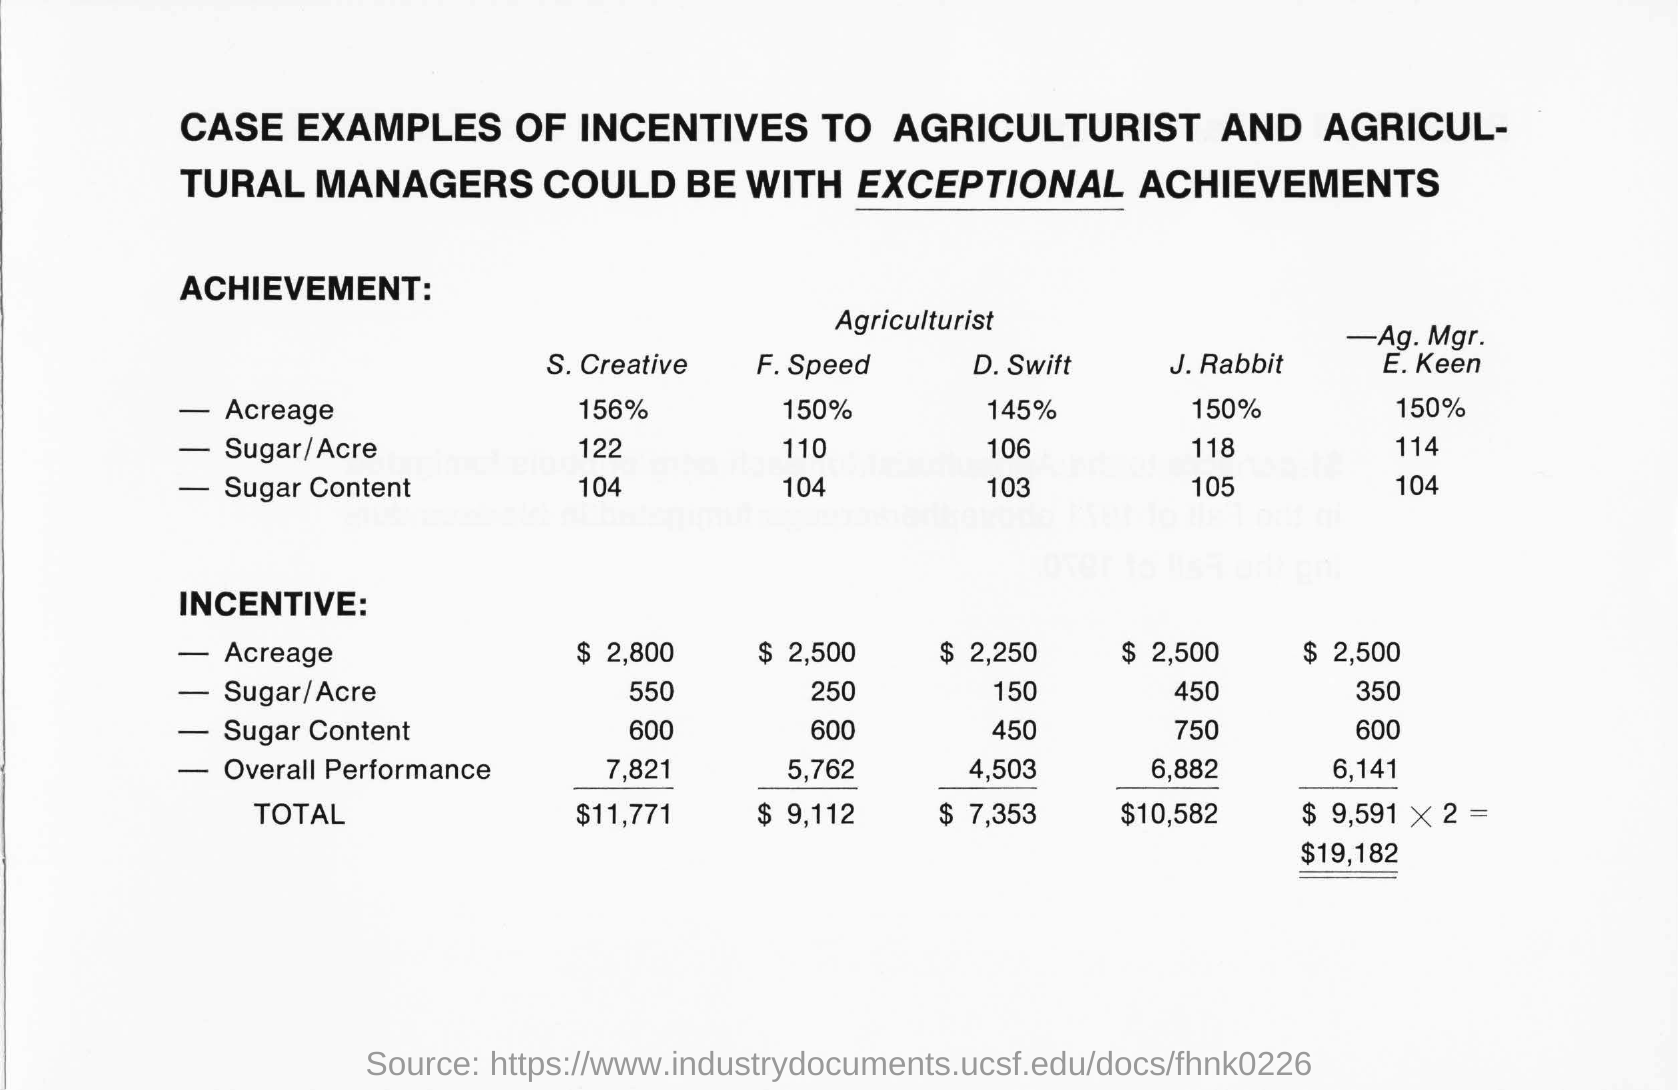Give some essential details in this illustration. The speed of the Acreage is 150% of what it was previously. The word 'EXCEPTIONAL' is underlined at the top of the document. 